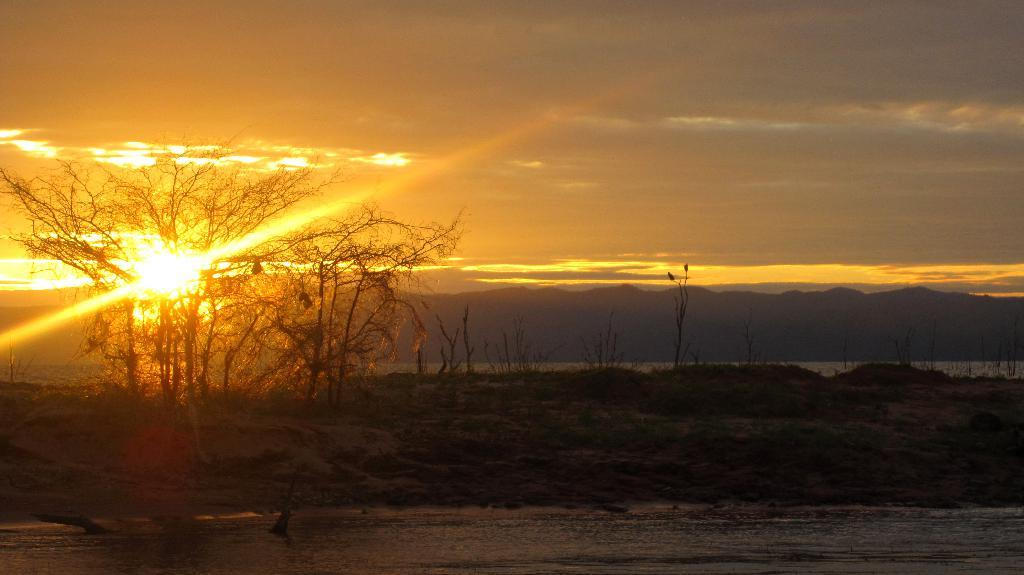What is covering the ground at the bottom of the image? There is water on the ground at the bottom of the image. What type of vegetation can be seen on the ground? There are bare trees and grass on the ground. What can be seen in the background of the image? There are mountains and water visible in the background of the image. What is visible in the sky? The sun is visible in the sky, and there are clouds present. What type of interest is being paid on the water in the image? There is no mention of interest or any financial context in the image; it simply depicts water on the ground. Can you see any frogs hopping around in the image? There are no frogs visible in the image. 